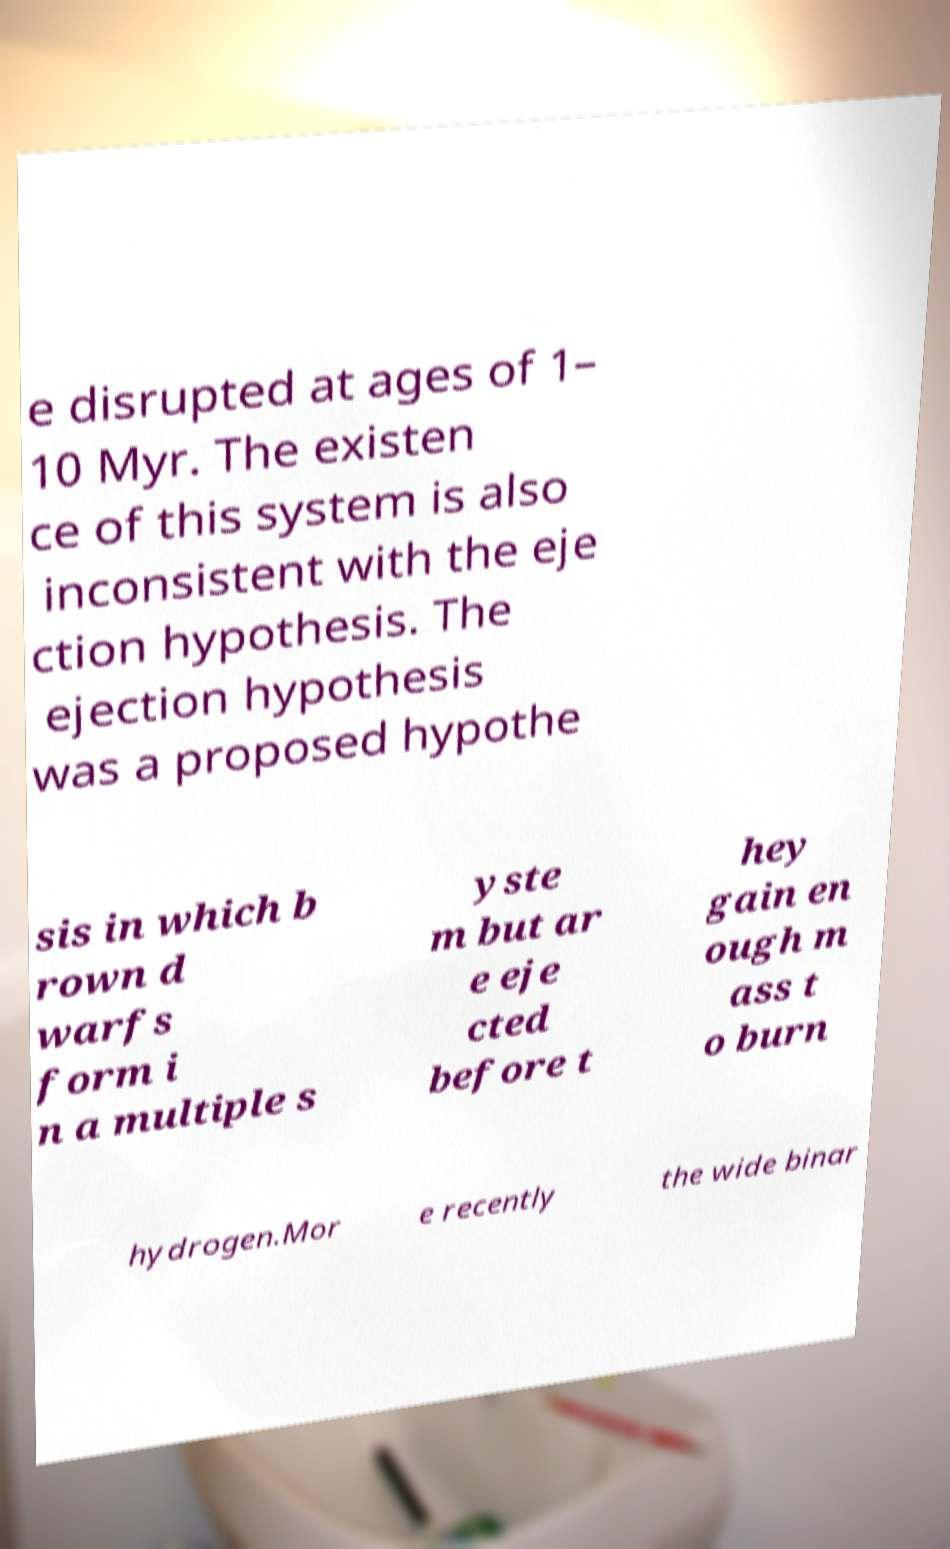For documentation purposes, I need the text within this image transcribed. Could you provide that? e disrupted at ages of 1– 10 Myr. The existen ce of this system is also inconsistent with the eje ction hypothesis. The ejection hypothesis was a proposed hypothe sis in which b rown d warfs form i n a multiple s yste m but ar e eje cted before t hey gain en ough m ass t o burn hydrogen.Mor e recently the wide binar 